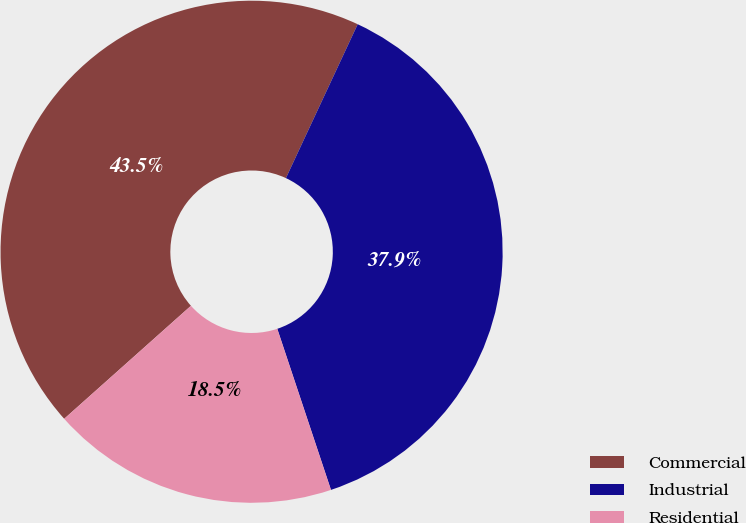Convert chart to OTSL. <chart><loc_0><loc_0><loc_500><loc_500><pie_chart><fcel>Commercial<fcel>Industrial<fcel>Residential<nl><fcel>43.53%<fcel>37.93%<fcel>18.53%<nl></chart> 